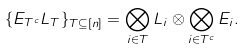Convert formula to latex. <formula><loc_0><loc_0><loc_500><loc_500>\{ E _ { T ^ { c } } L _ { T } \} _ { T \subseteq [ n ] } = \bigotimes _ { i \in T } L _ { i } \otimes \bigotimes _ { i \in T ^ { c } } E _ { i } .</formula> 